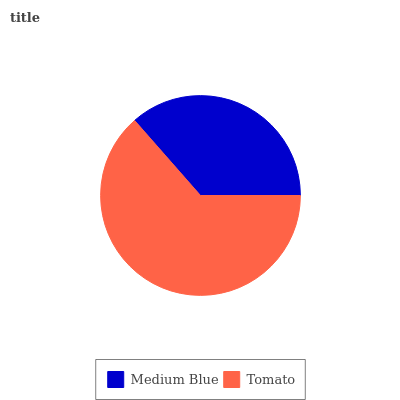Is Medium Blue the minimum?
Answer yes or no. Yes. Is Tomato the maximum?
Answer yes or no. Yes. Is Tomato the minimum?
Answer yes or no. No. Is Tomato greater than Medium Blue?
Answer yes or no. Yes. Is Medium Blue less than Tomato?
Answer yes or no. Yes. Is Medium Blue greater than Tomato?
Answer yes or no. No. Is Tomato less than Medium Blue?
Answer yes or no. No. Is Tomato the high median?
Answer yes or no. Yes. Is Medium Blue the low median?
Answer yes or no. Yes. Is Medium Blue the high median?
Answer yes or no. No. Is Tomato the low median?
Answer yes or no. No. 